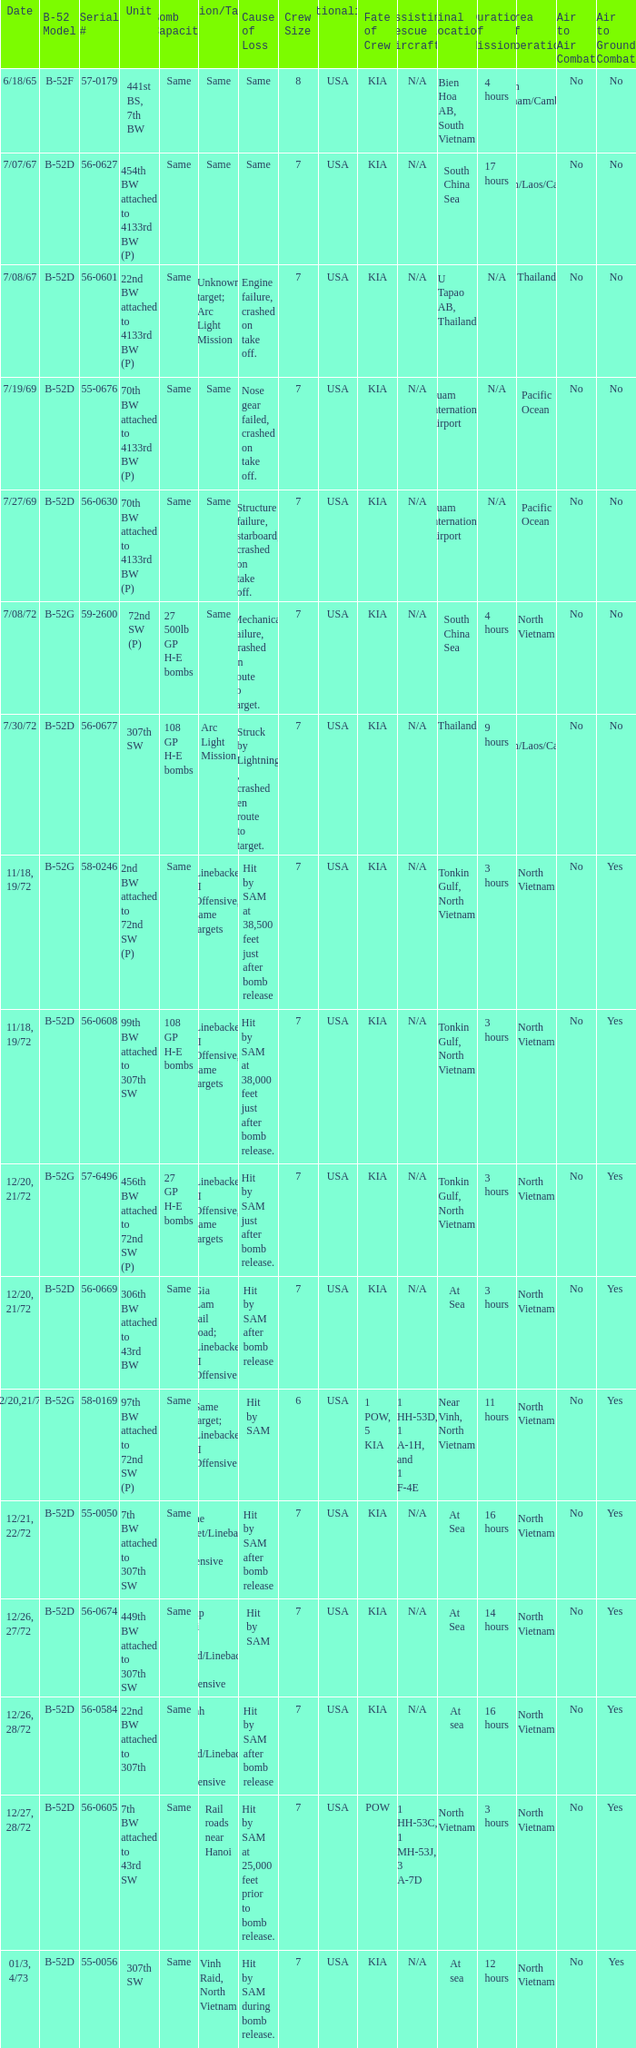When 441st bs, 7th bw is the unit what is the b-52 model? B-52F. 